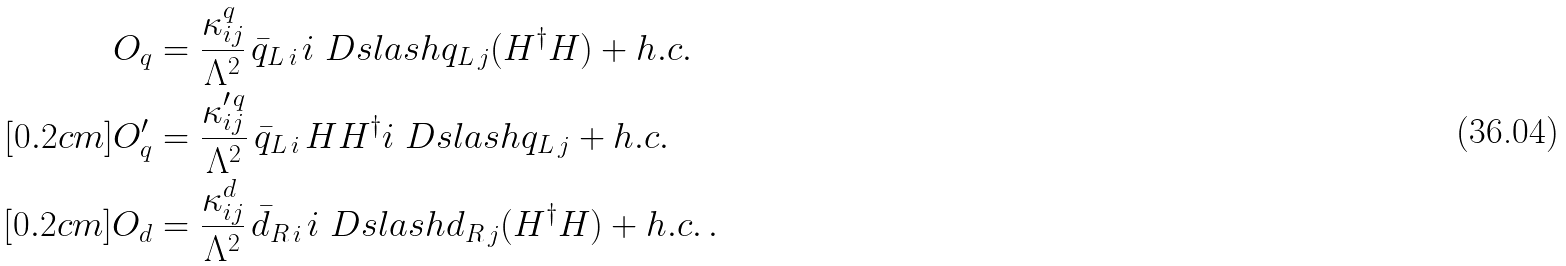<formula> <loc_0><loc_0><loc_500><loc_500>O _ { q } & = \frac { \kappa ^ { q } _ { i j } } { \Lambda ^ { 2 } } \, \bar { q } _ { L \, i \, } i \ D s l a s h q _ { L \, j } ( H ^ { \dagger } H ) + h . c . \\ [ 0 . 2 c m ] O _ { q } ^ { \prime } & = \frac { \kappa ^ { \prime \, q } _ { i j } } { \Lambda ^ { 2 } } \, \bar { q } _ { L \, i \, } H H ^ { \dagger } i \ D s l a s h q _ { L \, j } + h . c . \\ [ 0 . 2 c m ] O _ { d } & = \frac { \kappa ^ { d } _ { i j } } { \Lambda ^ { 2 } } \, \bar { d } _ { R \, i \, } i \ D s l a s h d _ { R \, j } ( H ^ { \dagger } H ) + h . c . \, .</formula> 